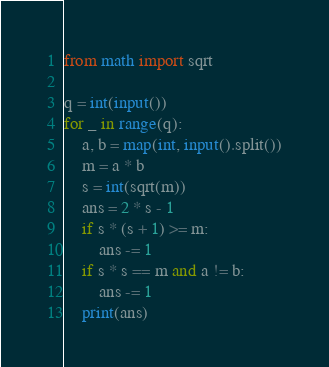Convert code to text. <code><loc_0><loc_0><loc_500><loc_500><_Python_>from math import sqrt

q = int(input())
for _ in range(q):
    a, b = map(int, input().split())
    m = a * b
    s = int(sqrt(m))
    ans = 2 * s - 1
    if s * (s + 1) >= m:
        ans -= 1
    if s * s == m and a != b:
        ans -= 1
    print(ans)
</code> 